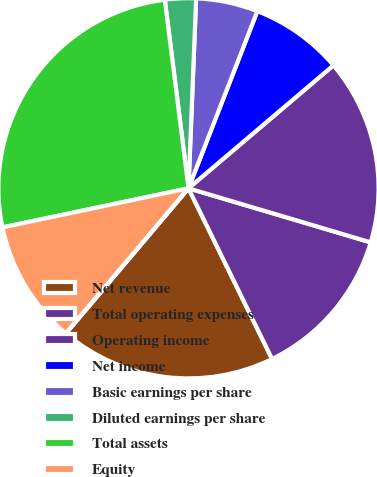Convert chart. <chart><loc_0><loc_0><loc_500><loc_500><pie_chart><fcel>Net revenue<fcel>Total operating expenses<fcel>Operating income<fcel>Net income<fcel>Basic earnings per share<fcel>Diluted earnings per share<fcel>Total assets<fcel>Equity<fcel>Cash dividends declared per<nl><fcel>18.42%<fcel>13.16%<fcel>15.79%<fcel>7.9%<fcel>5.26%<fcel>2.63%<fcel>26.31%<fcel>10.53%<fcel>0.0%<nl></chart> 